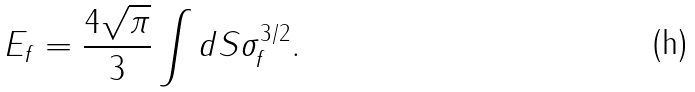Convert formula to latex. <formula><loc_0><loc_0><loc_500><loc_500>E _ { f } = \frac { 4 \sqrt { \pi } } { 3 } \int d S \sigma _ { f } ^ { 3 / 2 } .</formula> 